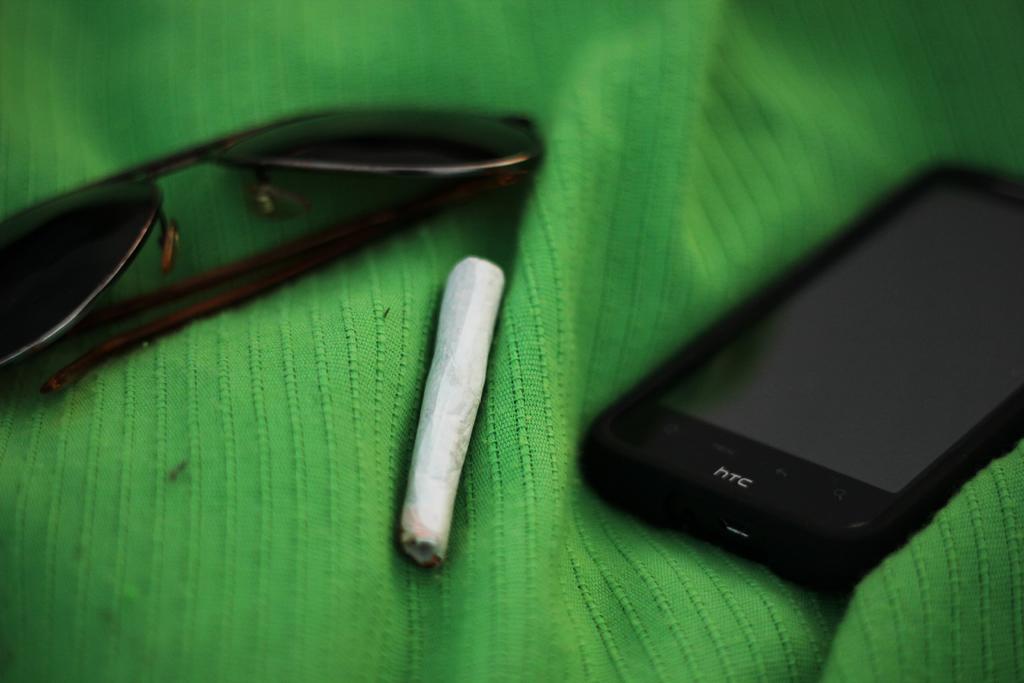What phone brand is seen here?
Give a very brief answer. Htc. 